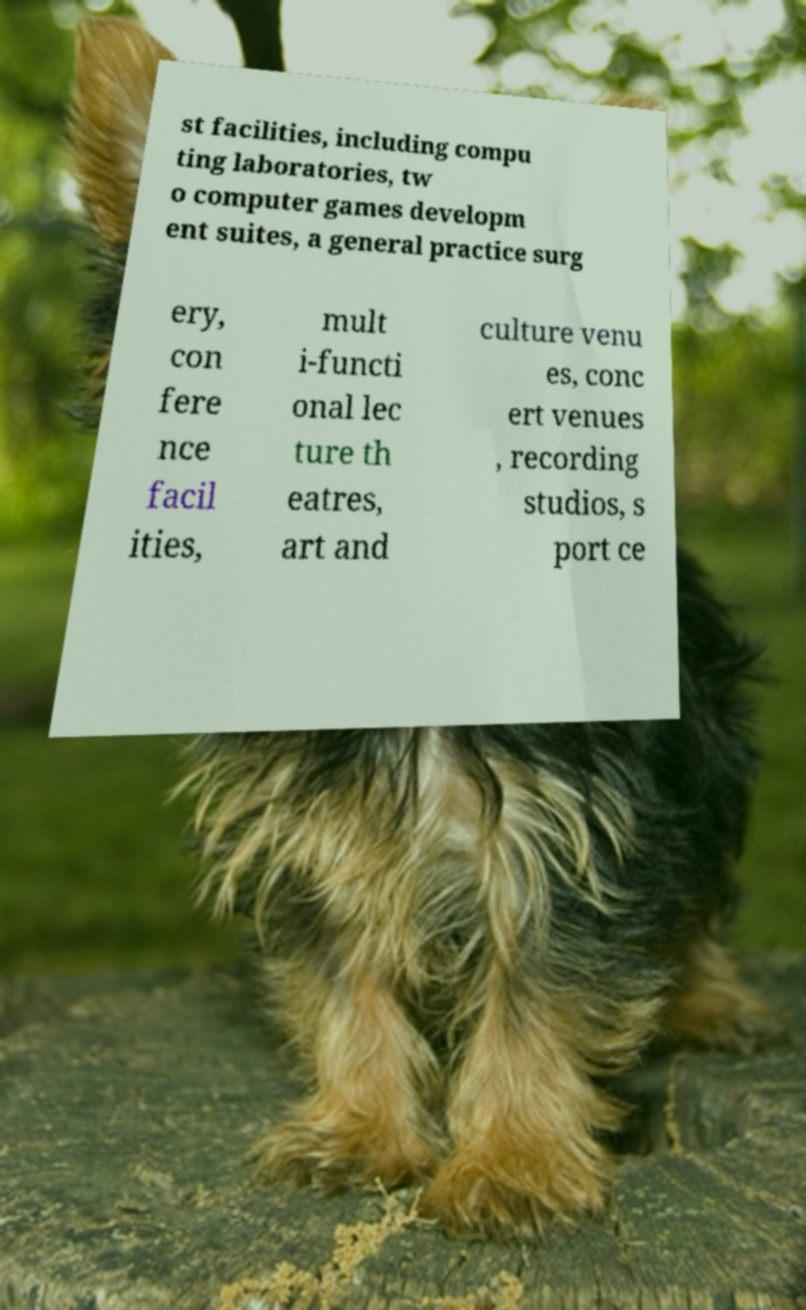Please identify and transcribe the text found in this image. st facilities, including compu ting laboratories, tw o computer games developm ent suites, a general practice surg ery, con fere nce facil ities, mult i-functi onal lec ture th eatres, art and culture venu es, conc ert venues , recording studios, s port ce 